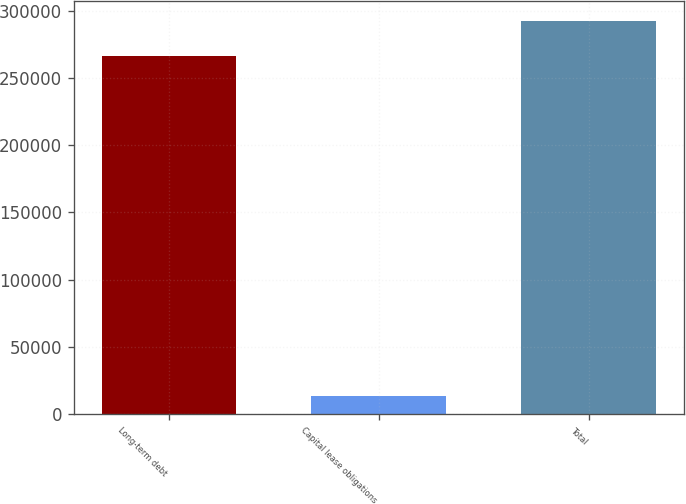Convert chart to OTSL. <chart><loc_0><loc_0><loc_500><loc_500><bar_chart><fcel>Long-term debt<fcel>Capital lease obligations<fcel>Total<nl><fcel>266250<fcel>13512<fcel>292875<nl></chart> 